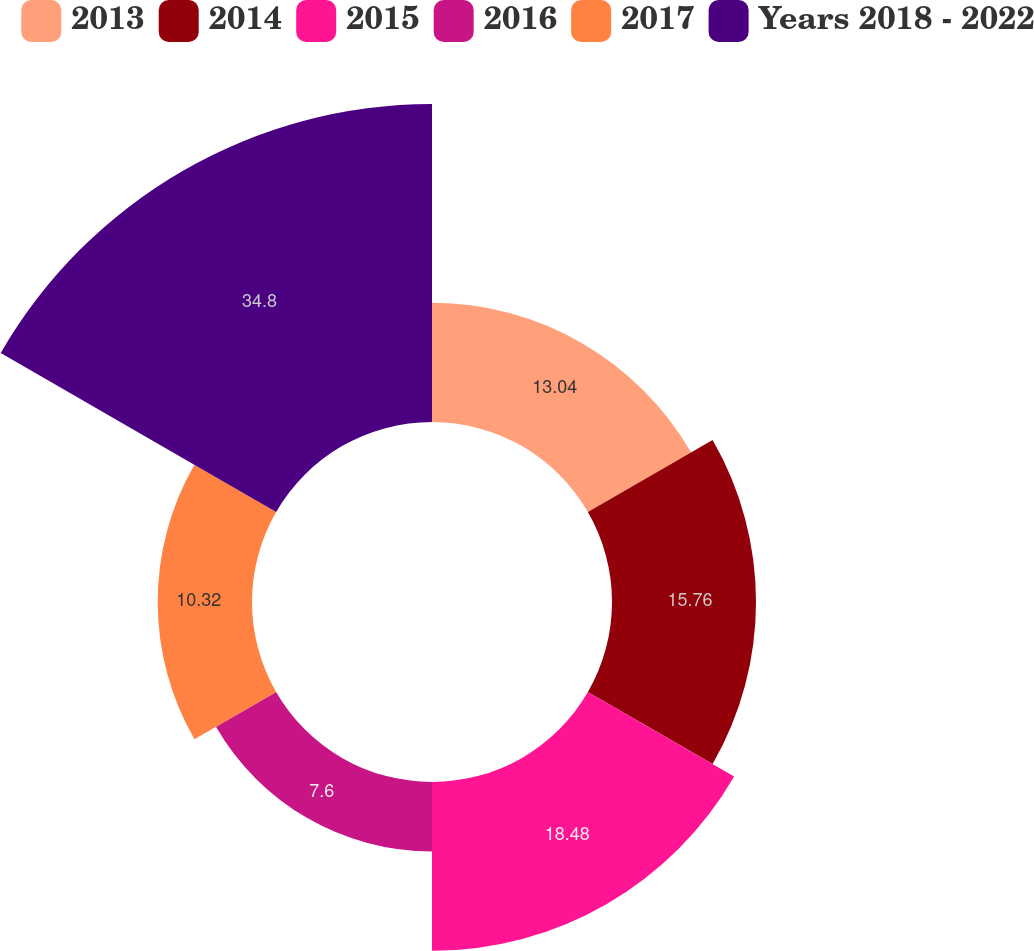Convert chart. <chart><loc_0><loc_0><loc_500><loc_500><pie_chart><fcel>2013<fcel>2014<fcel>2015<fcel>2016<fcel>2017<fcel>Years 2018 - 2022<nl><fcel>13.04%<fcel>15.76%<fcel>18.48%<fcel>7.6%<fcel>10.32%<fcel>34.8%<nl></chart> 